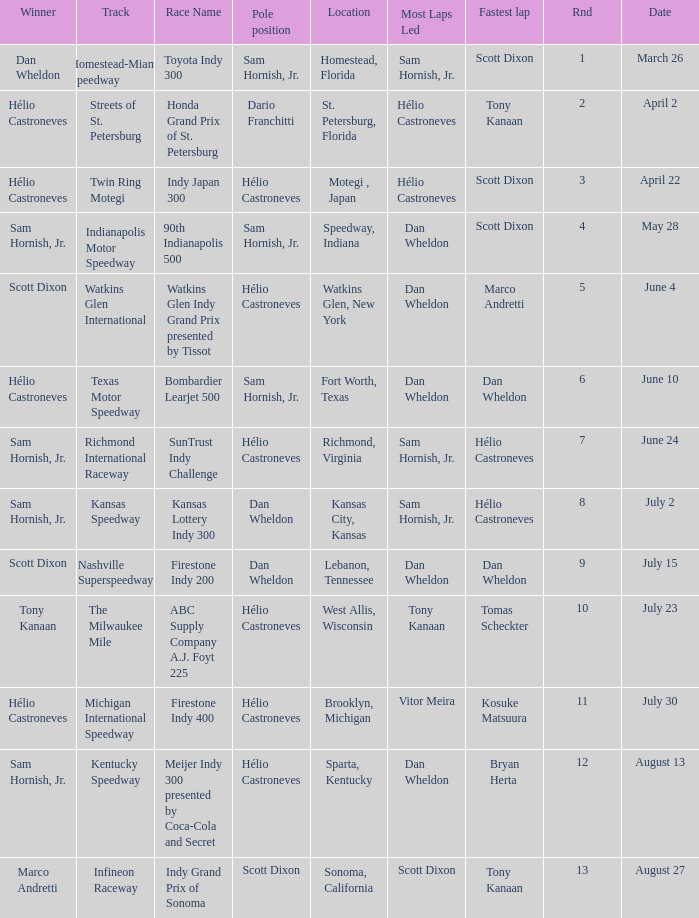How many times is the location is homestead, florida? 1.0. 